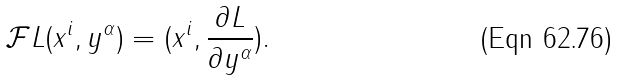<formula> <loc_0><loc_0><loc_500><loc_500>{ \mathcal { F } } { L } ( x ^ { i } , y ^ { \alpha } ) = ( x ^ { i } , \frac { \partial L } { \partial y ^ { \alpha } } ) .</formula> 